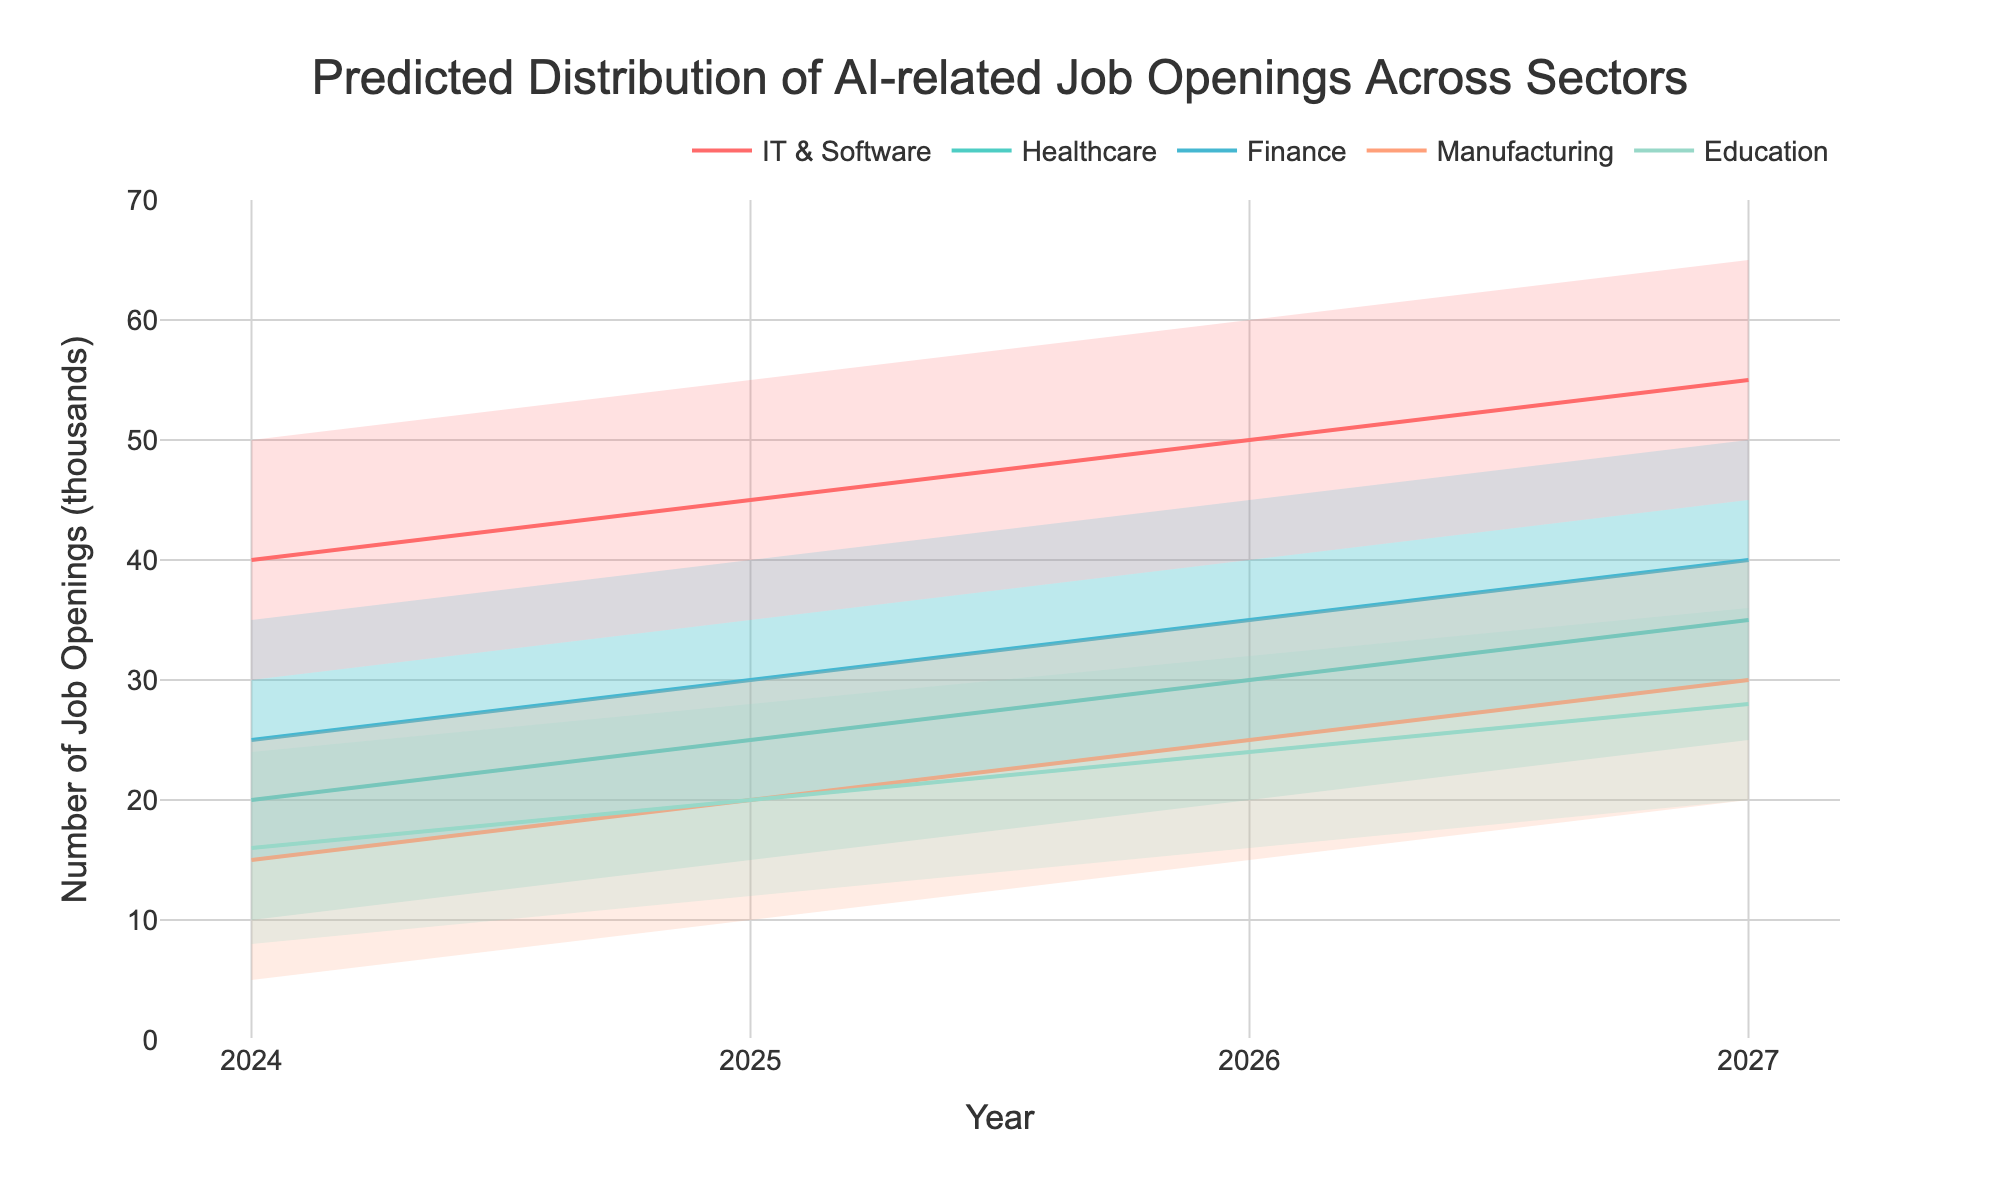What is the title of the figure? The title is located at the top center of the figure and reads "Predicted Distribution of AI-related Job Openings Across Sectors"
Answer: Predicted Distribution of AI-related Job Openings Across Sectors In which year does the IT & Software sector have the highest predicted job openings in the mid scenario? By looking at the plot, the mid-line for IT & Software reaches its highest value in 2027
Answer: 2027 Compare the mid estimates for Healthcare and Finance sectors in 2026. Which one is higher and by how much? The mid estimates for Healthcare and Finance in 2026 can be found on the plot; Healthcare is at 30, and Finance is at 35. Subtract the smaller value from the larger one: 35 - 30 = 5
Answer: Finance by 5 What is the range of predicted job openings for the Manufacturing sector in 2025? The range is determined by the low and high estimates in 2025 for the Manufacturing sector: 10 (low) to 30 (high)
Answer: 10 to 30 Which sector shows the most consistent growth in predicted job openings from 2024 to 2027? By examining the plot, IT & Software shows a consistent upward trend in the mid-line from 2024 to 2027
Answer: IT & Software What is the difference in the median value of job openings between the Education sector in 2025 and 2026? The mid or median value in 2025 for Education is 20, and in 2026, it is 24. Subtract the 2025 value from the 2026 value: 24 - 20 = 4
Answer: 4 In 2026, what is the total number of predicted AI job openings considering the high estimate for all sectors? Sum the high estimates for all sectors in 2026: IT & Software (60) + Healthcare (40) + Finance (45) + Manufacturing (35) + Education (32) = 212
Answer: 212 Do any sectors show overlapping ranges of predicted job openings in 2024? If yes, which sectors? By looking at the shaded areas, Finance (15-35) and Healthcare (10-30) overlap between 15 and 30
Answer: Yes, Finance and Healthcare 